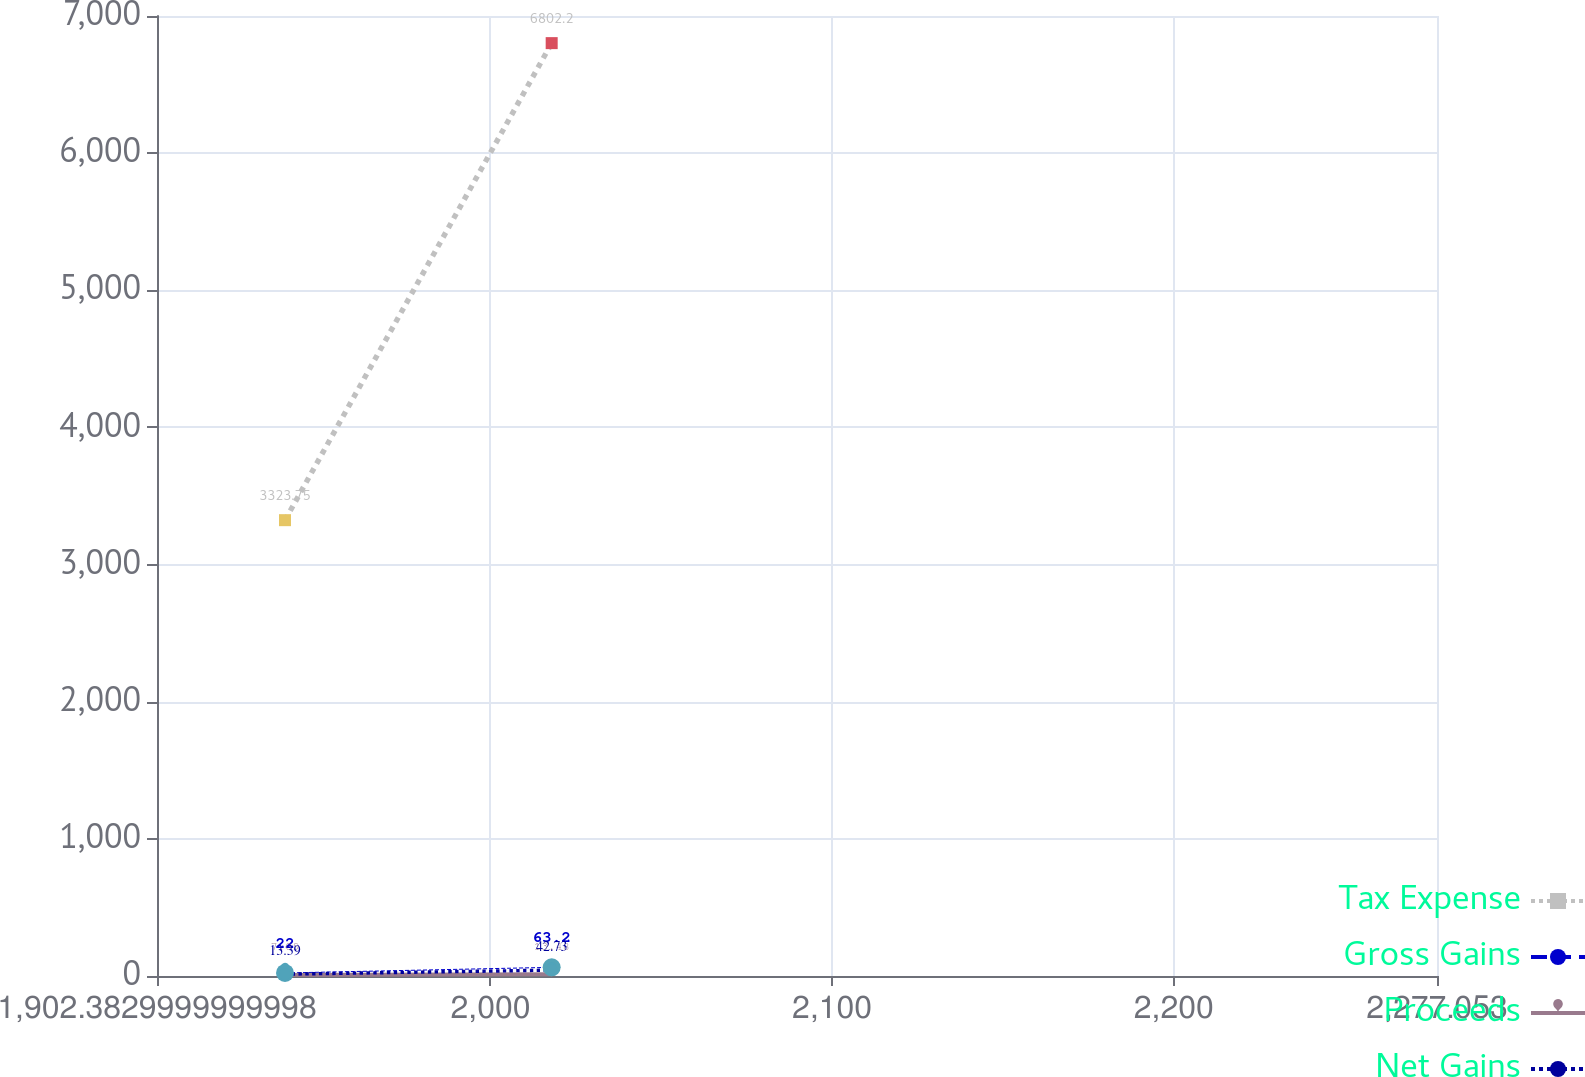Convert chart. <chart><loc_0><loc_0><loc_500><loc_500><line_chart><ecel><fcel>Tax Expense<fcel>Gross Gains<fcel>Proceeds<fcel>Net Gains<nl><fcel>1939.85<fcel>3323.75<fcel>22<fcel>7.09<fcel>13.39<nl><fcel>2017.91<fcel>6802.2<fcel>63.2<fcel>13.48<fcel>42.73<nl><fcel>2314.52<fcel>4529.63<fcel>27.04<fcel>28.06<fcel>4.56<nl></chart> 